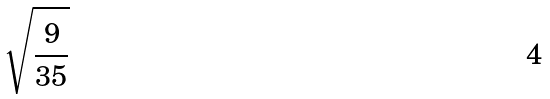Convert formula to latex. <formula><loc_0><loc_0><loc_500><loc_500>\sqrt { \frac { 9 } { 3 5 } }</formula> 